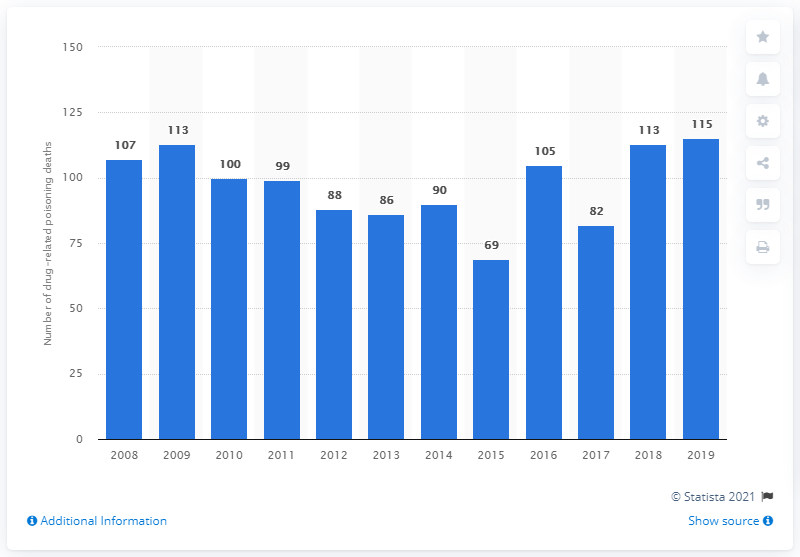Identify some key points in this picture. In 2019, the highest number of drug poisoning deaths in Denmark was 115. 